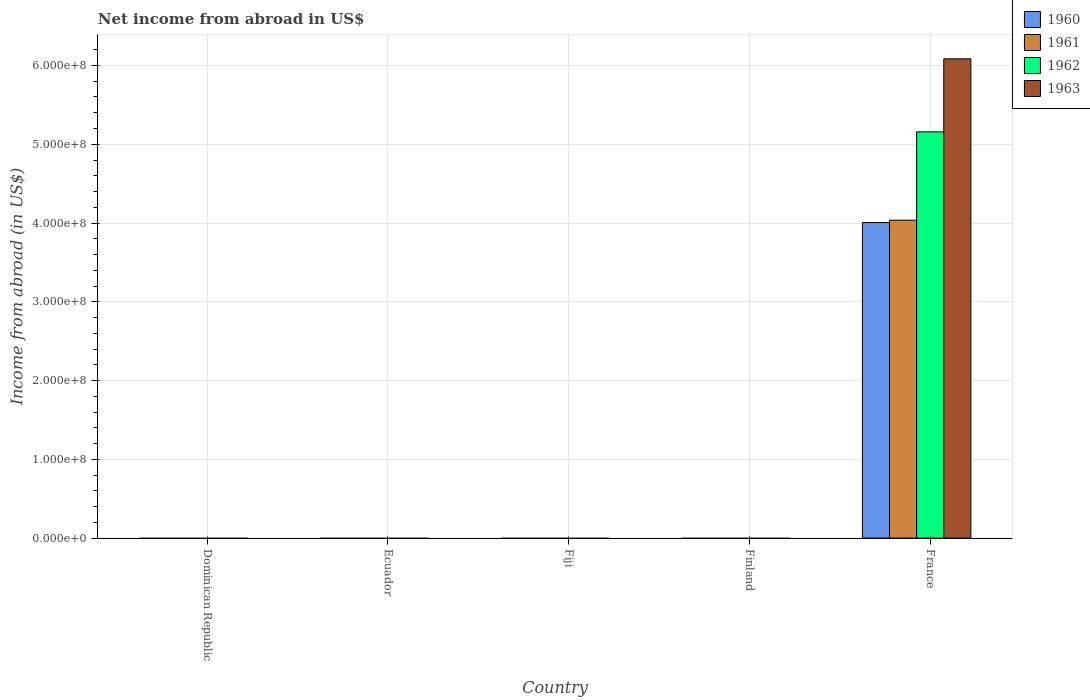Are the number of bars per tick equal to the number of legend labels?
Your answer should be compact. No. Are the number of bars on each tick of the X-axis equal?
Provide a short and direct response. No. How many bars are there on the 4th tick from the left?
Ensure brevity in your answer.  0. What is the label of the 3rd group of bars from the left?
Give a very brief answer. Fiji. In how many cases, is the number of bars for a given country not equal to the number of legend labels?
Provide a succinct answer. 4. What is the net income from abroad in 1962 in Ecuador?
Ensure brevity in your answer.  0. Across all countries, what is the maximum net income from abroad in 1960?
Your response must be concise. 4.01e+08. Across all countries, what is the minimum net income from abroad in 1961?
Your answer should be compact. 0. In which country was the net income from abroad in 1963 maximum?
Your answer should be very brief. France. What is the total net income from abroad in 1960 in the graph?
Ensure brevity in your answer.  4.01e+08. What is the difference between the net income from abroad in 1960 in Finland and the net income from abroad in 1961 in Dominican Republic?
Provide a short and direct response. 0. What is the average net income from abroad in 1960 per country?
Your response must be concise. 8.01e+07. What is the difference between the net income from abroad of/in 1960 and net income from abroad of/in 1962 in France?
Give a very brief answer. -1.15e+08. What is the difference between the highest and the lowest net income from abroad in 1960?
Your answer should be compact. 4.01e+08. How many bars are there?
Keep it short and to the point. 4. Are all the bars in the graph horizontal?
Make the answer very short. No. How many countries are there in the graph?
Provide a short and direct response. 5. What is the difference between two consecutive major ticks on the Y-axis?
Give a very brief answer. 1.00e+08. Are the values on the major ticks of Y-axis written in scientific E-notation?
Provide a short and direct response. Yes. Where does the legend appear in the graph?
Give a very brief answer. Top right. How many legend labels are there?
Offer a terse response. 4. What is the title of the graph?
Your answer should be compact. Net income from abroad in US$. Does "1974" appear as one of the legend labels in the graph?
Ensure brevity in your answer.  No. What is the label or title of the X-axis?
Offer a very short reply. Country. What is the label or title of the Y-axis?
Provide a short and direct response. Income from abroad (in US$). What is the Income from abroad (in US$) of 1963 in Dominican Republic?
Keep it short and to the point. 0. What is the Income from abroad (in US$) in 1961 in Ecuador?
Your response must be concise. 0. What is the Income from abroad (in US$) of 1962 in Ecuador?
Offer a very short reply. 0. What is the Income from abroad (in US$) of 1960 in Fiji?
Give a very brief answer. 0. What is the Income from abroad (in US$) of 1961 in Fiji?
Your response must be concise. 0. What is the Income from abroad (in US$) of 1963 in Fiji?
Your answer should be very brief. 0. What is the Income from abroad (in US$) in 1960 in Finland?
Provide a short and direct response. 0. What is the Income from abroad (in US$) in 1961 in Finland?
Your answer should be very brief. 0. What is the Income from abroad (in US$) of 1962 in Finland?
Keep it short and to the point. 0. What is the Income from abroad (in US$) of 1963 in Finland?
Your answer should be very brief. 0. What is the Income from abroad (in US$) of 1960 in France?
Make the answer very short. 4.01e+08. What is the Income from abroad (in US$) of 1961 in France?
Your answer should be very brief. 4.04e+08. What is the Income from abroad (in US$) in 1962 in France?
Offer a very short reply. 5.16e+08. What is the Income from abroad (in US$) of 1963 in France?
Make the answer very short. 6.08e+08. Across all countries, what is the maximum Income from abroad (in US$) of 1960?
Offer a very short reply. 4.01e+08. Across all countries, what is the maximum Income from abroad (in US$) of 1961?
Provide a succinct answer. 4.04e+08. Across all countries, what is the maximum Income from abroad (in US$) in 1962?
Offer a very short reply. 5.16e+08. Across all countries, what is the maximum Income from abroad (in US$) of 1963?
Give a very brief answer. 6.08e+08. Across all countries, what is the minimum Income from abroad (in US$) in 1960?
Your answer should be compact. 0. Across all countries, what is the minimum Income from abroad (in US$) in 1962?
Your response must be concise. 0. Across all countries, what is the minimum Income from abroad (in US$) in 1963?
Give a very brief answer. 0. What is the total Income from abroad (in US$) in 1960 in the graph?
Your response must be concise. 4.01e+08. What is the total Income from abroad (in US$) in 1961 in the graph?
Provide a short and direct response. 4.04e+08. What is the total Income from abroad (in US$) in 1962 in the graph?
Offer a terse response. 5.16e+08. What is the total Income from abroad (in US$) of 1963 in the graph?
Provide a succinct answer. 6.08e+08. What is the average Income from abroad (in US$) of 1960 per country?
Ensure brevity in your answer.  8.01e+07. What is the average Income from abroad (in US$) in 1961 per country?
Your response must be concise. 8.07e+07. What is the average Income from abroad (in US$) of 1962 per country?
Your response must be concise. 1.03e+08. What is the average Income from abroad (in US$) in 1963 per country?
Ensure brevity in your answer.  1.22e+08. What is the difference between the Income from abroad (in US$) of 1960 and Income from abroad (in US$) of 1961 in France?
Keep it short and to the point. -3.05e+06. What is the difference between the Income from abroad (in US$) in 1960 and Income from abroad (in US$) in 1962 in France?
Give a very brief answer. -1.15e+08. What is the difference between the Income from abroad (in US$) in 1960 and Income from abroad (in US$) in 1963 in France?
Your answer should be compact. -2.08e+08. What is the difference between the Income from abroad (in US$) of 1961 and Income from abroad (in US$) of 1962 in France?
Ensure brevity in your answer.  -1.12e+08. What is the difference between the Income from abroad (in US$) of 1961 and Income from abroad (in US$) of 1963 in France?
Your answer should be compact. -2.05e+08. What is the difference between the Income from abroad (in US$) of 1962 and Income from abroad (in US$) of 1963 in France?
Your response must be concise. -9.27e+07. What is the difference between the highest and the lowest Income from abroad (in US$) in 1960?
Make the answer very short. 4.01e+08. What is the difference between the highest and the lowest Income from abroad (in US$) in 1961?
Provide a succinct answer. 4.04e+08. What is the difference between the highest and the lowest Income from abroad (in US$) in 1962?
Make the answer very short. 5.16e+08. What is the difference between the highest and the lowest Income from abroad (in US$) of 1963?
Give a very brief answer. 6.08e+08. 